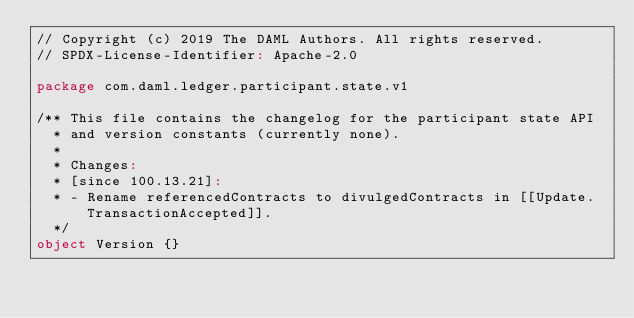Convert code to text. <code><loc_0><loc_0><loc_500><loc_500><_Scala_>// Copyright (c) 2019 The DAML Authors. All rights reserved.
// SPDX-License-Identifier: Apache-2.0

package com.daml.ledger.participant.state.v1

/** This file contains the changelog for the participant state API
  * and version constants (currently none).
  *
  * Changes:
  * [since 100.13.21]:
  * - Rename referencedContracts to divulgedContracts in [[Update.TransactionAccepted]].
  */
object Version {}
</code> 